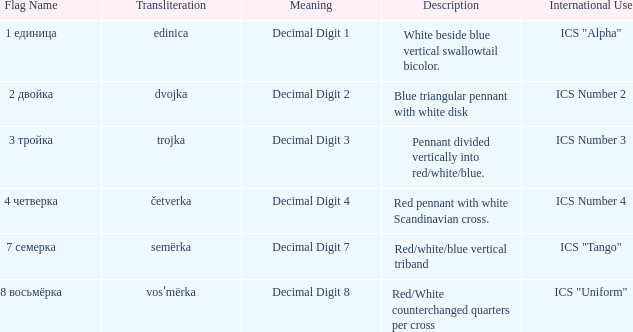How many diverse accounts are there for the flag denoting decimal digit 2? 1.0. 